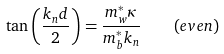<formula> <loc_0><loc_0><loc_500><loc_500>\tan \left ( { \frac { k _ { n } d } { 2 } } \right ) = { \frac { m _ { w } ^ { * } \kappa } { m _ { b } ^ { * } k _ { n } } } \quad ( e v e n )</formula> 